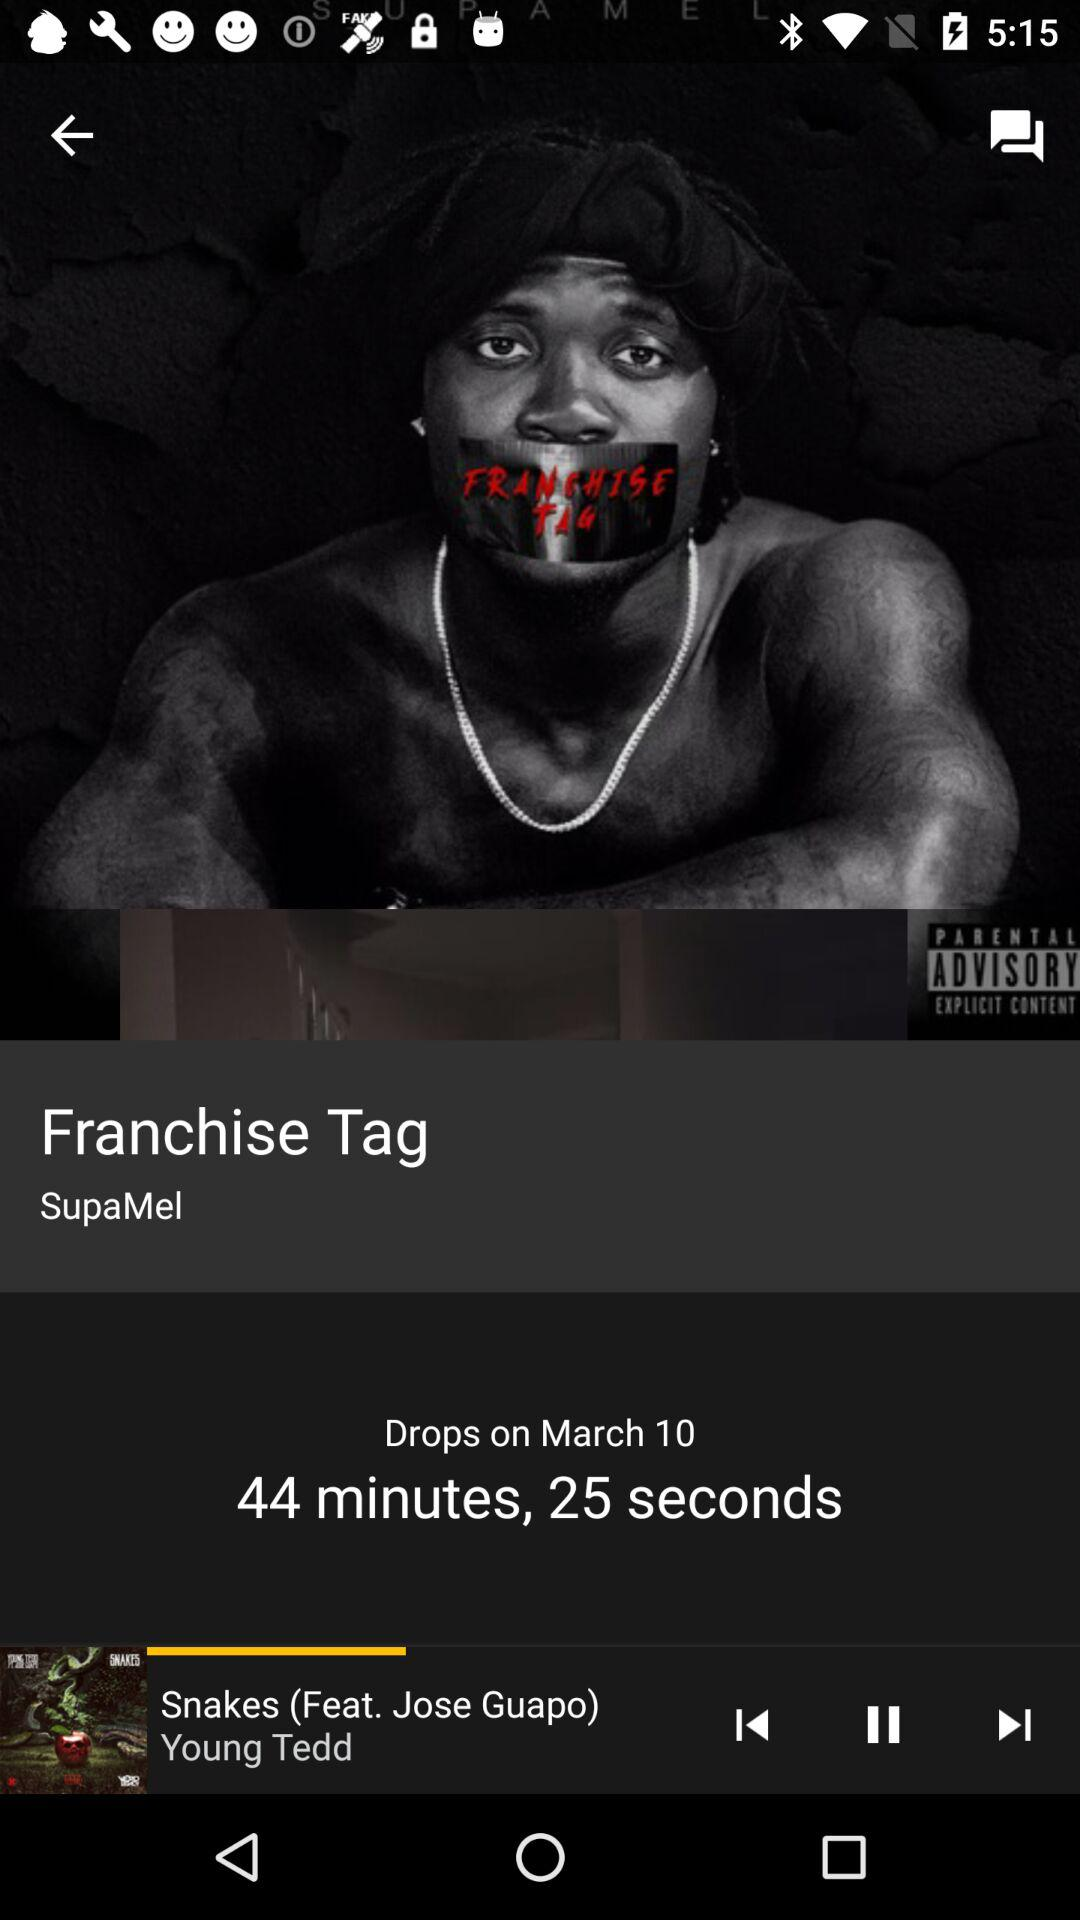What is the date? The date is March 10. 